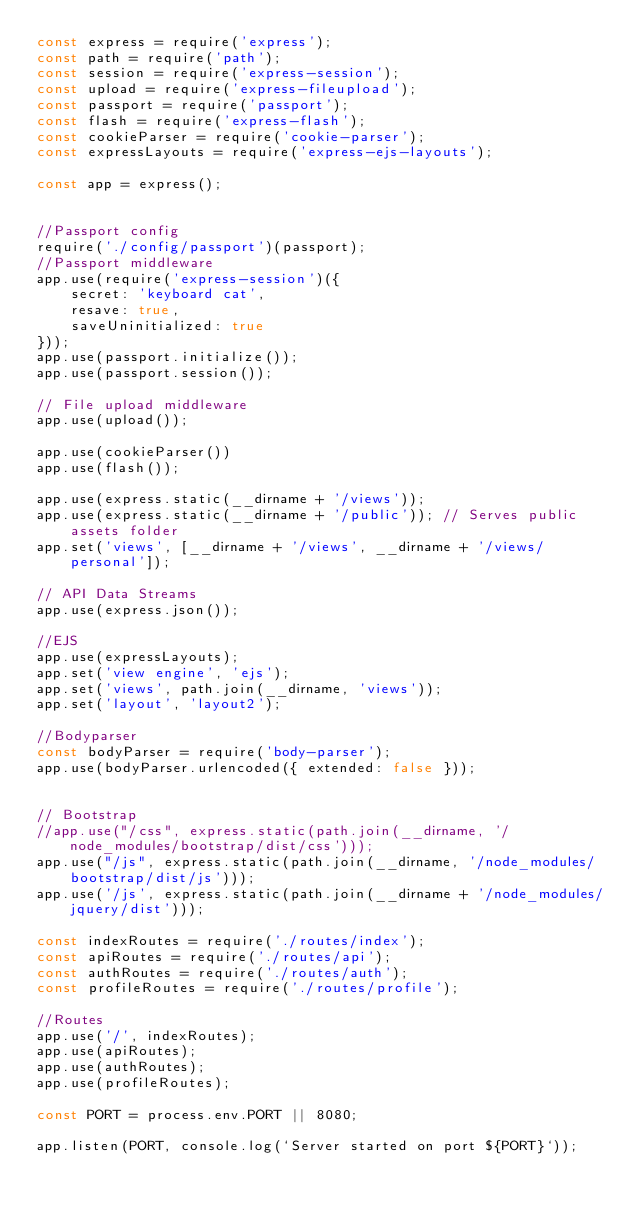<code> <loc_0><loc_0><loc_500><loc_500><_JavaScript_>const express = require('express');
const path = require('path');
const session = require('express-session');
const upload = require('express-fileupload');
const passport = require('passport');
const flash = require('express-flash');
const cookieParser = require('cookie-parser');
const expressLayouts = require('express-ejs-layouts');

const app = express();


//Passport config
require('./config/passport')(passport);
//Passport middleware
app.use(require('express-session')({
    secret: 'keyboard cat',
    resave: true,
    saveUninitialized: true
}));
app.use(passport.initialize());
app.use(passport.session());

// File upload middleware
app.use(upload());

app.use(cookieParser())
app.use(flash());

app.use(express.static(__dirname + '/views'));
app.use(express.static(__dirname + '/public')); // Serves public assets folder
app.set('views', [__dirname + '/views', __dirname + '/views/personal']);

// API Data Streams
app.use(express.json());

//EJS
app.use(expressLayouts);
app.set('view engine', 'ejs');
app.set('views', path.join(__dirname, 'views'));
app.set('layout', 'layout2');

//Bodyparser
const bodyParser = require('body-parser');
app.use(bodyParser.urlencoded({ extended: false }));


// Bootstrap
//app.use("/css", express.static(path.join(__dirname, '/node_modules/bootstrap/dist/css')));
app.use("/js", express.static(path.join(__dirname, '/node_modules/bootstrap/dist/js')));
app.use('/js', express.static(path.join(__dirname + '/node_modules/jquery/dist')));

const indexRoutes = require('./routes/index');
const apiRoutes = require('./routes/api');
const authRoutes = require('./routes/auth');
const profileRoutes = require('./routes/profile');

//Routes
app.use('/', indexRoutes);
app.use(apiRoutes);
app.use(authRoutes);
app.use(profileRoutes);

const PORT = process.env.PORT || 8080;

app.listen(PORT, console.log(`Server started on port ${PORT}`));</code> 